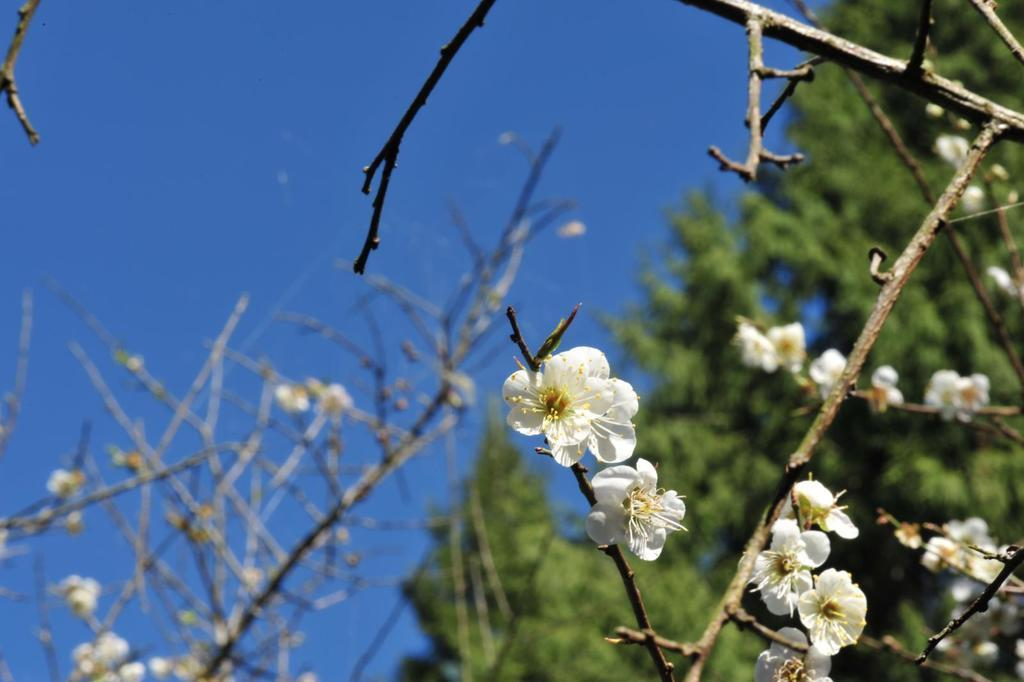What type of vegetation can be seen in the image? There are trees in the image. What color is the sky in the image? The sky is blue in the image. How many stones are present in the image? There is no mention of stones in the image, so it is impossible to determine their number. Can you see any snails on the trees in the image? There is no mention of snails in the image, so it is impossible to determine if they are present. 